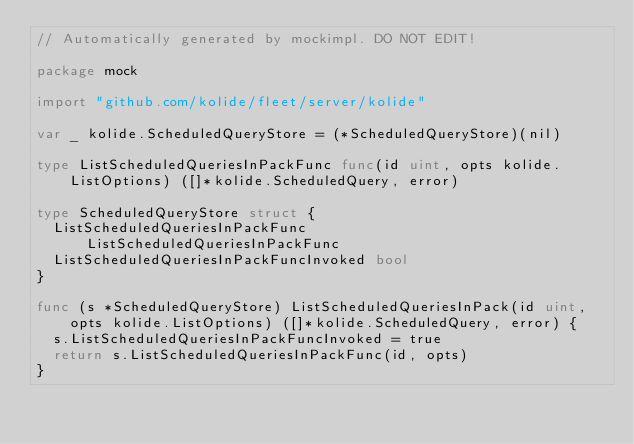<code> <loc_0><loc_0><loc_500><loc_500><_Go_>// Automatically generated by mockimpl. DO NOT EDIT!

package mock

import "github.com/kolide/fleet/server/kolide"

var _ kolide.ScheduledQueryStore = (*ScheduledQueryStore)(nil)

type ListScheduledQueriesInPackFunc func(id uint, opts kolide.ListOptions) ([]*kolide.ScheduledQuery, error)

type ScheduledQueryStore struct {
	ListScheduledQueriesInPackFunc        ListScheduledQueriesInPackFunc
	ListScheduledQueriesInPackFuncInvoked bool
}

func (s *ScheduledQueryStore) ListScheduledQueriesInPack(id uint, opts kolide.ListOptions) ([]*kolide.ScheduledQuery, error) {
	s.ListScheduledQueriesInPackFuncInvoked = true
	return s.ListScheduledQueriesInPackFunc(id, opts)
}
</code> 